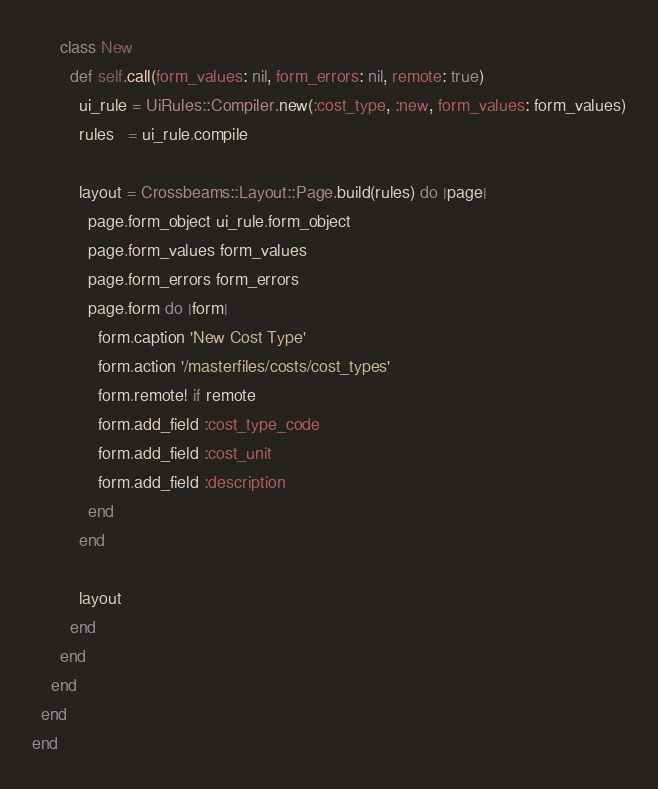<code> <loc_0><loc_0><loc_500><loc_500><_Ruby_>      class New
        def self.call(form_values: nil, form_errors: nil, remote: true)
          ui_rule = UiRules::Compiler.new(:cost_type, :new, form_values: form_values)
          rules   = ui_rule.compile

          layout = Crossbeams::Layout::Page.build(rules) do |page|
            page.form_object ui_rule.form_object
            page.form_values form_values
            page.form_errors form_errors
            page.form do |form|
              form.caption 'New Cost Type'
              form.action '/masterfiles/costs/cost_types'
              form.remote! if remote
              form.add_field :cost_type_code
              form.add_field :cost_unit
              form.add_field :description
            end
          end

          layout
        end
      end
    end
  end
end
</code> 